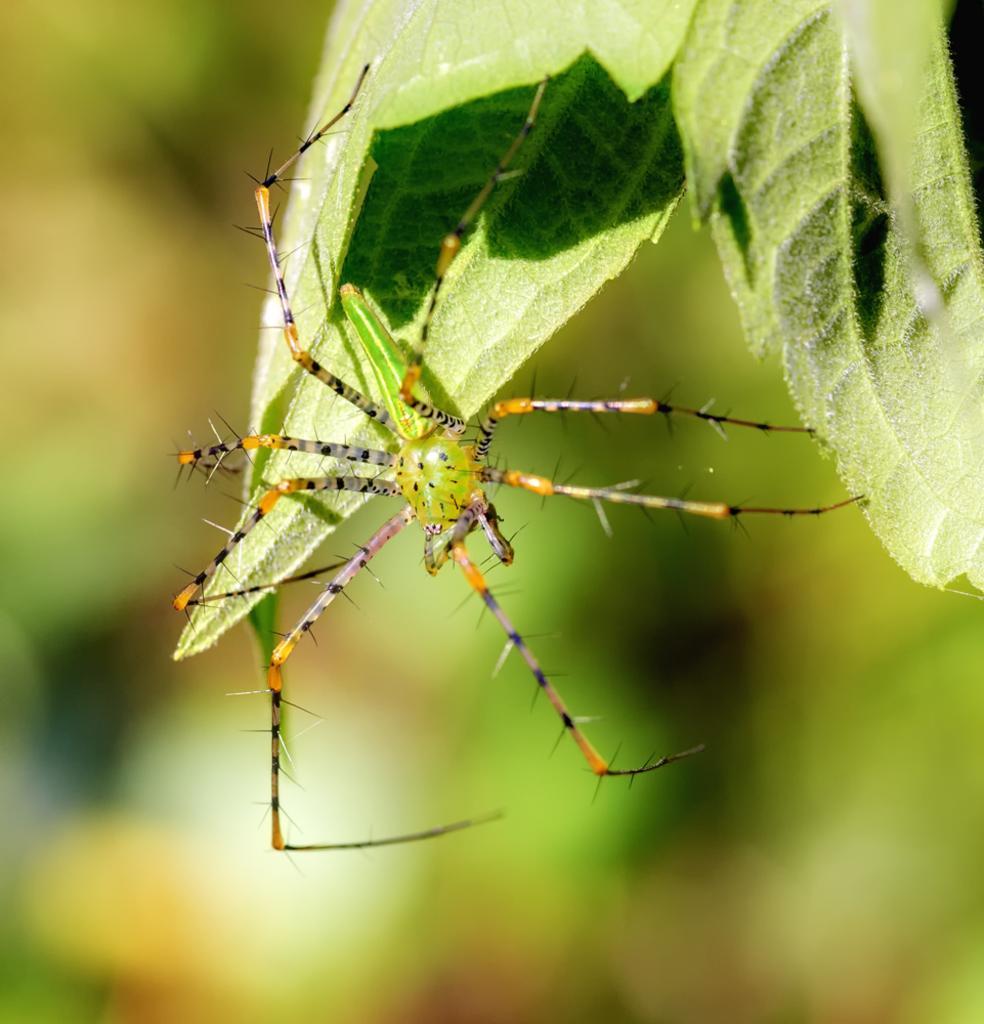Please provide a concise description of this image. In this image we can see an insect on leaves and the background is blurred. 